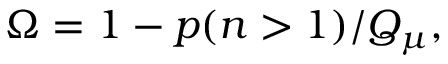<formula> <loc_0><loc_0><loc_500><loc_500>\Omega = 1 - p ( n > 1 ) / Q _ { \mu } ,</formula> 